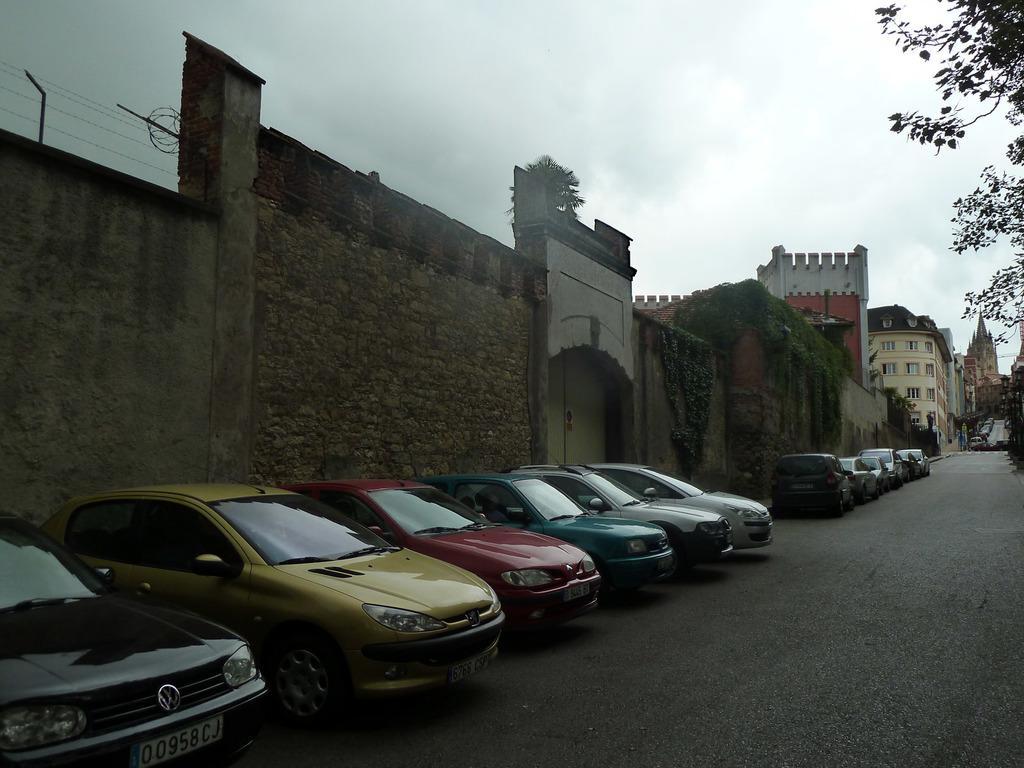In one or two sentences, can you explain what this image depicts? This picture shows few cars parked and we see buildings and trees and a wall and we see a cloudy sky. 